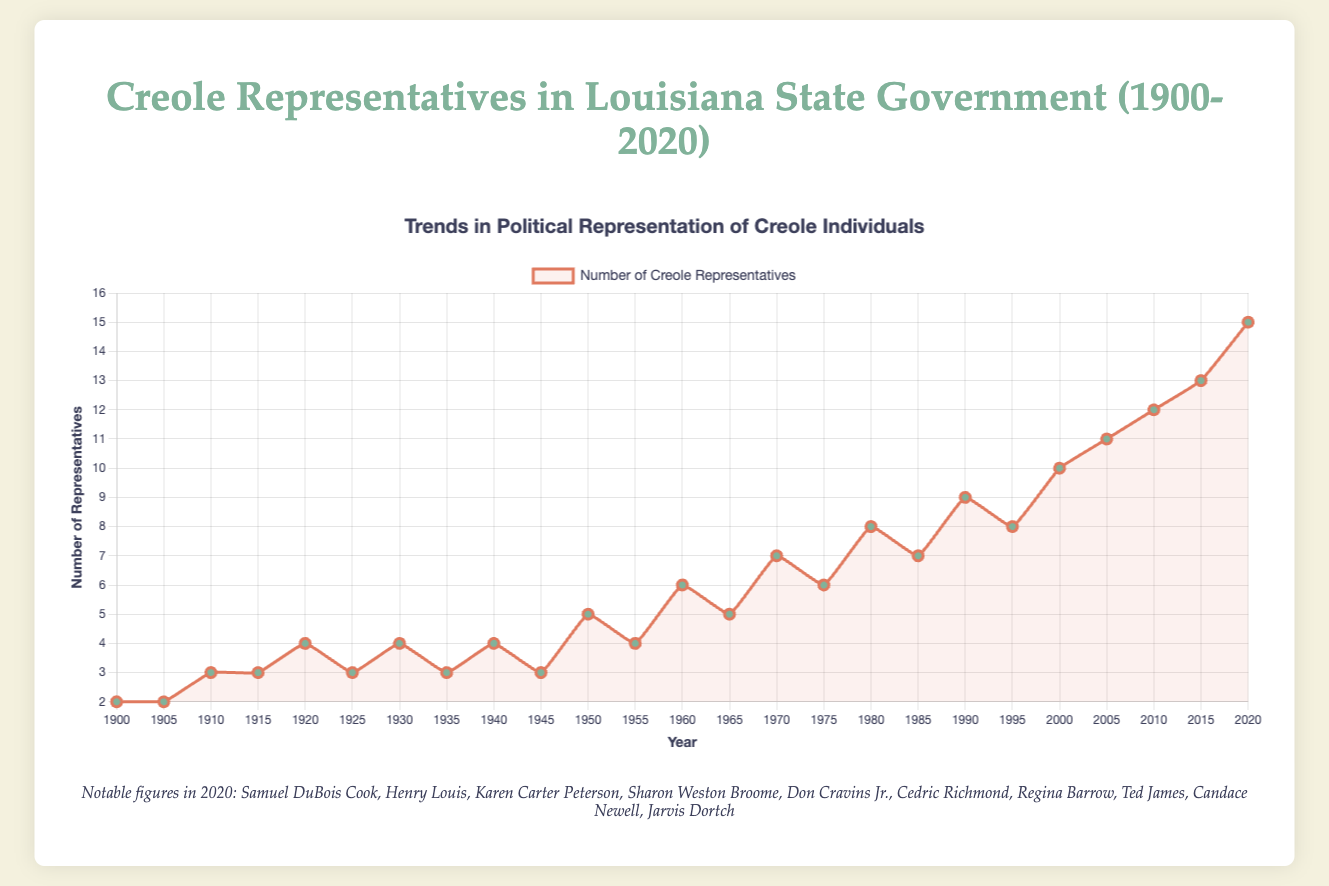How did the number of Creole representatives change between 1900 and 1950? To determine this, note the number of representatives in 1900 (2) and in 1950 (5). Subtract the earlier value from the later one: 5 - 2 = 3.
Answer: Increased by 3 What is the overall trend in the number of Creole representatives between 1900 and 2020? By visually inspecting the line plot, we observe a consistent increasing trend from 2 representatives in 1900 to 15 representatives in 2020, indicating significant growth over the period.
Answer: Increasing Between which two years did the number of Creole representatives first reach 10? Observe the plot and note the year before and the year when the value reaches 10. The values reach 10 in the year 2000. The year before that is 1995 with a value of 8.
Answer: 1995 and 2000 How many Creole representatives were added between 1980 and 2000? Note the number of representatives in 1980 (8) and in 2000 (10). Subtract the earlier number from the later one: 10 - 8 = 2.
Answer: 2 During which decade did the number of Creole representatives jump from 4 to 5 for the first time? Look at the corresponding years for 4 and 5 representatives. The jump from 4 to 5 occurred between 1945 (4) and 1950 (5).
Answer: 1940s Which year had the largest number of Creole representatives and how many were there? By inspecting the end of the plot, we see the maximum value of 15 in the year 2020.
Answer: 2020 with 15 representatives In which years did the number of representatives decrease from the previous tally? Inspect the chart to identify any downward slopes. These decreases occurred between 1925 and 1930 (4 to 3), 1930 and 1935 (4 to 3), 1940 and 1945 (4 to 3), 1950 and 1955 (5 to 4), 1960 and 1965 (6 to 5), and 1980 and 1985 (8 to 7).
Answer: 1925-1930, 1930-1935, 1940-1945, 1950-1955, 1960-1965, 1980-1985 On average, by how many representatives did the number increase each decade from 1900 to 2020? First, find the total increase over the entire period: 15 (in 2020) - 2 (in 1900) = 13. Then, divide by the number of decades (12 decades from 1900 to 2020 inclusive): 13 / 12 ≈ 1.083.
Answer: Approximately 1.083 representatives per decade What is the difference in the number of Creole representatives between the highest and lowest points on the chart? Identify the highest value (15 in 2020) and the lowest value (2 in 1900). The difference is 15 - 2 = 13.
Answer: 13 